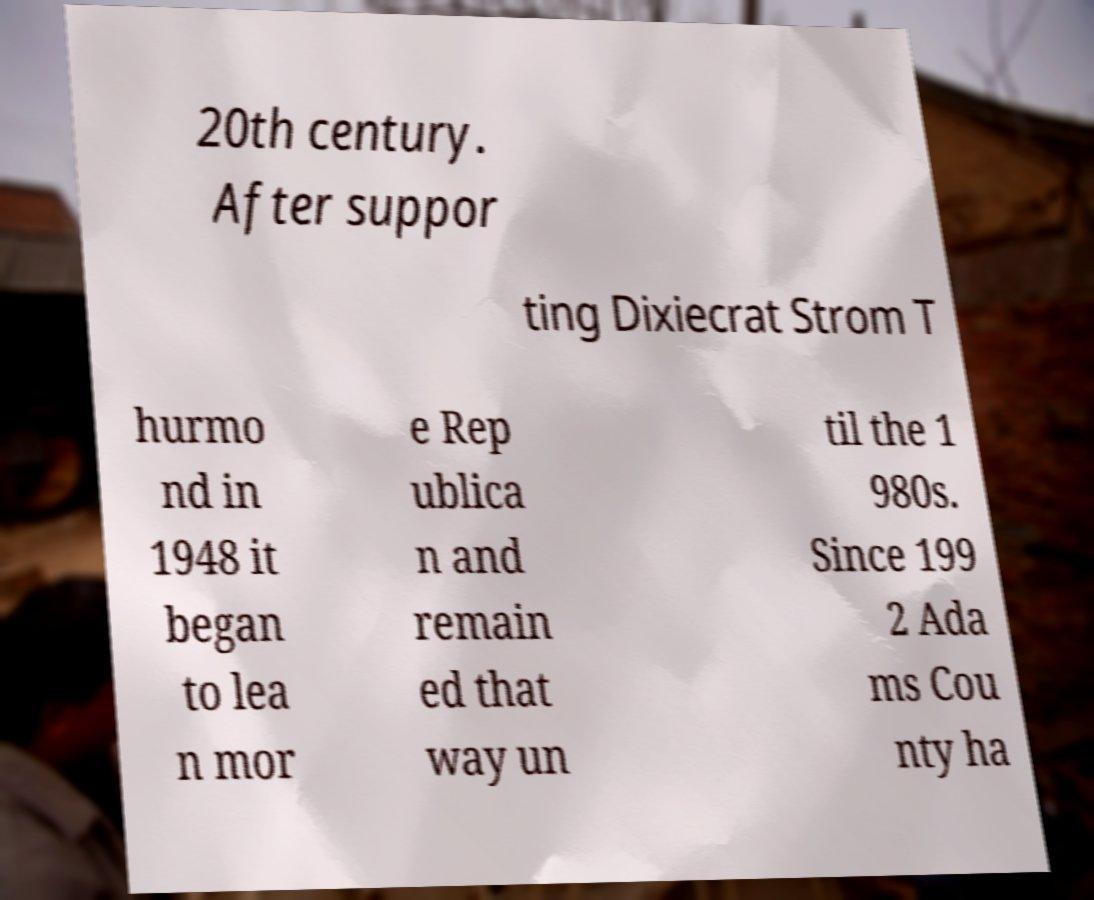Could you extract and type out the text from this image? 20th century. After suppor ting Dixiecrat Strom T hurmo nd in 1948 it began to lea n mor e Rep ublica n and remain ed that way un til the 1 980s. Since 199 2 Ada ms Cou nty ha 